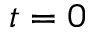Convert formula to latex. <formula><loc_0><loc_0><loc_500><loc_500>t = 0</formula> 